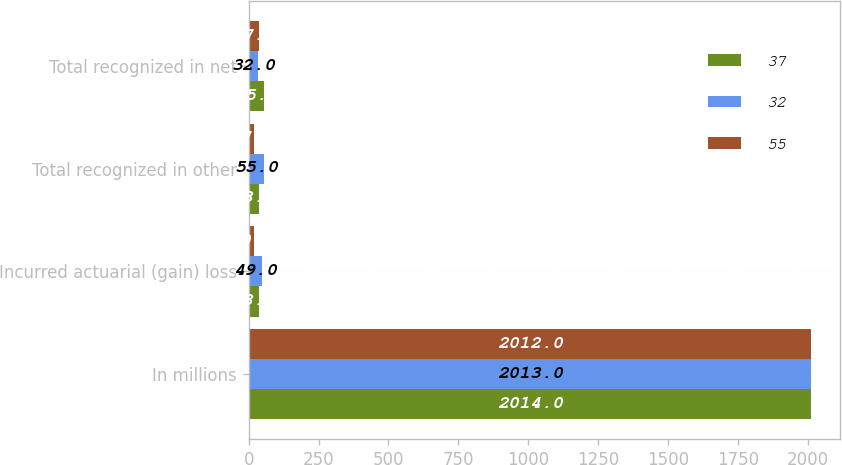<chart> <loc_0><loc_0><loc_500><loc_500><stacked_bar_chart><ecel><fcel>In millions<fcel>Incurred actuarial (gain) loss<fcel>Total recognized in other<fcel>Total recognized in net<nl><fcel>37<fcel>2014<fcel>38<fcel>38<fcel>55<nl><fcel>32<fcel>2013<fcel>49<fcel>55<fcel>32<nl><fcel>55<fcel>2012<fcel>20<fcel>17<fcel>37<nl></chart> 